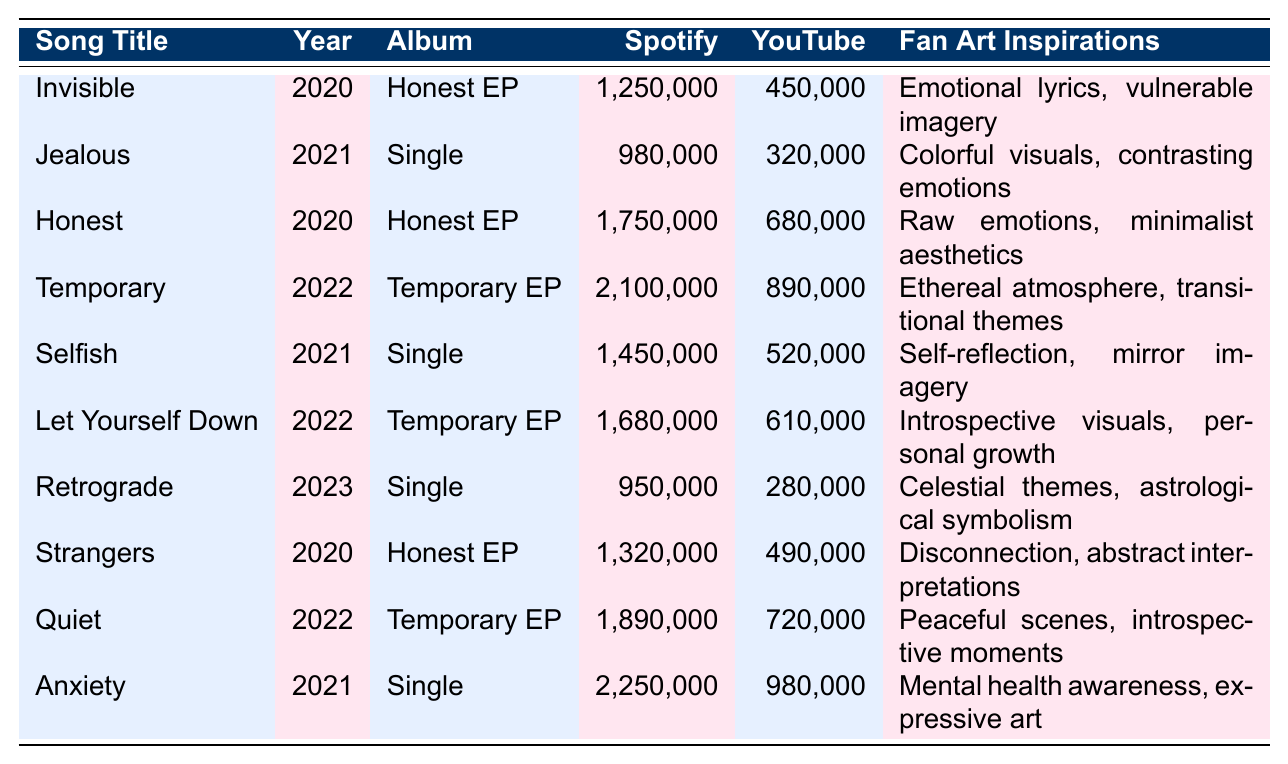What is the total number of Spotify streams for the songs released in 2022? We identify the songs from 2022, which are "Temporary" and "Let Yourself Down." Their Spotify streams are 2,100,000 and 1,680,000 respectively. Adding these gives us 2,100,000 + 1,680,000 = 3,780,000.
Answer: 3,780,000 Which song has the highest YouTube views? Looking through the YouTube views column, "Anxiety" has 980,000 views, which is the highest compared to the others in the list.
Answer: Anxiety Did "Invisible" have more Spotify streams than "Jealous"? "Invisible" has 1,250,000 Spotify streams while "Jealous" has 980,000. Since 1,250,000 is greater than 980,000, the statement is true.
Answer: Yes What is the average number of YouTube views for the songs in the "Temporary EP"? The songs from the "Temporary EP" are "Temporary," "Let Yourself Down," and "Quiet," with YouTube views of 890,000, 610,000, and 720,000. The sum is 890,000 + 610,000 + 720,000 = 2,220,000, and dividing by 3 gives the average as 2,220,000 / 3 = 740,000.
Answer: 740,000 Which song released in 2021 had the most Spotify streams? The songs released in 2021 are "Jealous," "Selfish," and "Anxiety." The Spotify streams for these are 980,000, 1,450,000, and 2,250,000 respectively. "Anxiety" has the highest with 2,250,000.
Answer: Anxiety How many more streams did "Temporary" receive compared to "Retrograde"? "Temporary" has 2,100,000 Spotify streams and "Retrograde" has 950,000. The difference is 2,100,000 - 950,000 = 1,150,000.
Answer: 1,150,000 Is there a song from "Honest EP" that has less YouTube views than "Retrograde"? "Retrograde" has 280,000 YouTube views. The songs from "Honest EP" are "Invisible" (450,000), "Honest" (680,000), and "Strangers" (490,000). All of these have more views than "Retrograde," so the statement is false.
Answer: No What is the total Spotify streams for all songs released before 2022? The songs released before 2022 are "Invisible," "Jealous," "Honest," "Strangers," and "Anxiety." Their Spotify streams total to 1,250,000 + 980,000 + 1,750,000 + 1,320,000 + 2,250,000 = 7,550,000.
Answer: 7,550,000 Which song inspired by mental health awareness has the least YouTube views? The song inspired by mental health awareness is "Anxiety," which has 980,000 views. Comparing this with other songs, "Retrograde" has 280,000 views which is less, and thus it does not apply as it isn't related to mental health. Hence, "Anxiety" is the only one considered with those views.
Answer: Anxiety 